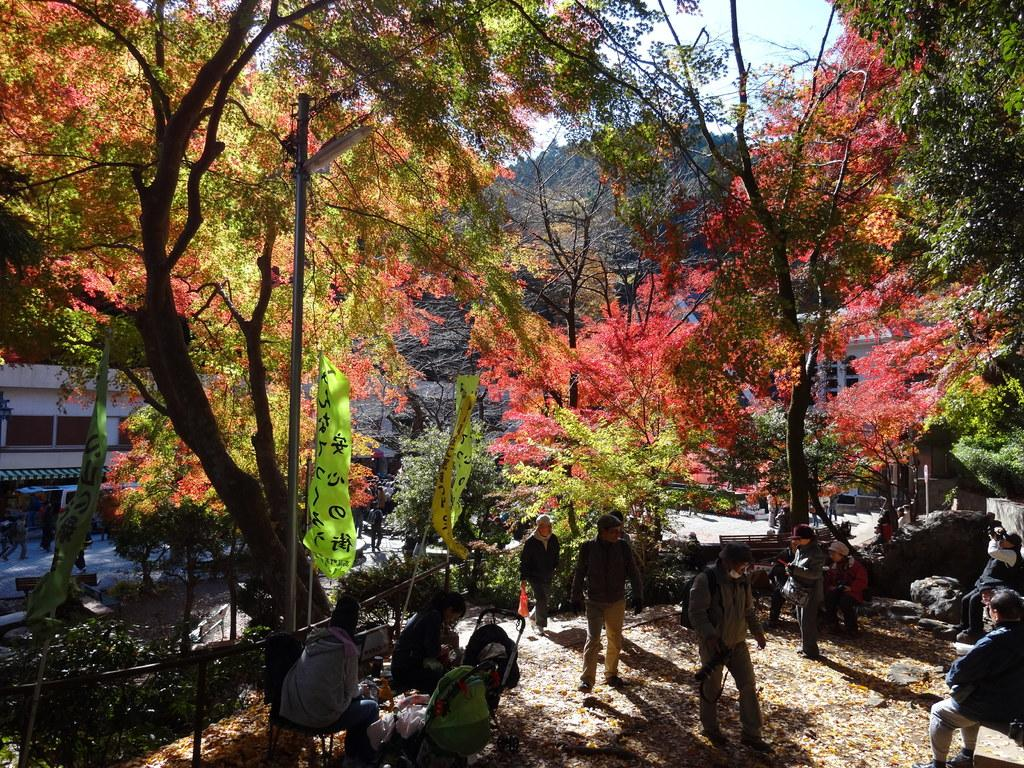How many people are in the image? There are persons in the image, but the exact number cannot be determined from the provided facts. What objects are present in the image besides the persons? There are stones, chairs, poles, and flags visible in the image. What can be seen in the background of the image? In the background of the image, there are trees, buildings, plants, and sky visible. What type of musical instrument is being played in the frame? There is no musical instrument or frame present in the image. How does the trail lead to the location in the image? There is no trail mentioned in the image, so it cannot be determined how it might lead to the location. 